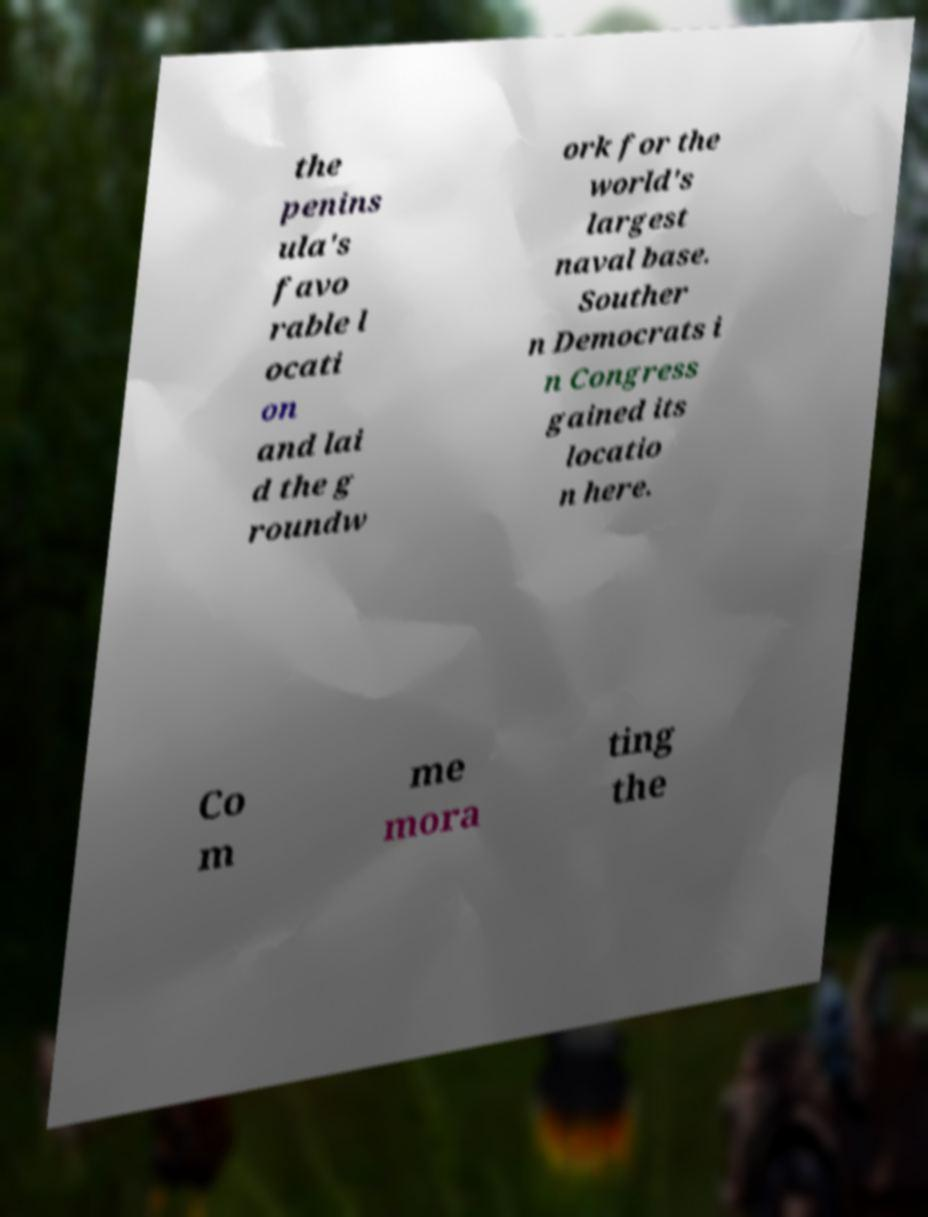Can you accurately transcribe the text from the provided image for me? the penins ula's favo rable l ocati on and lai d the g roundw ork for the world's largest naval base. Souther n Democrats i n Congress gained its locatio n here. Co m me mora ting the 